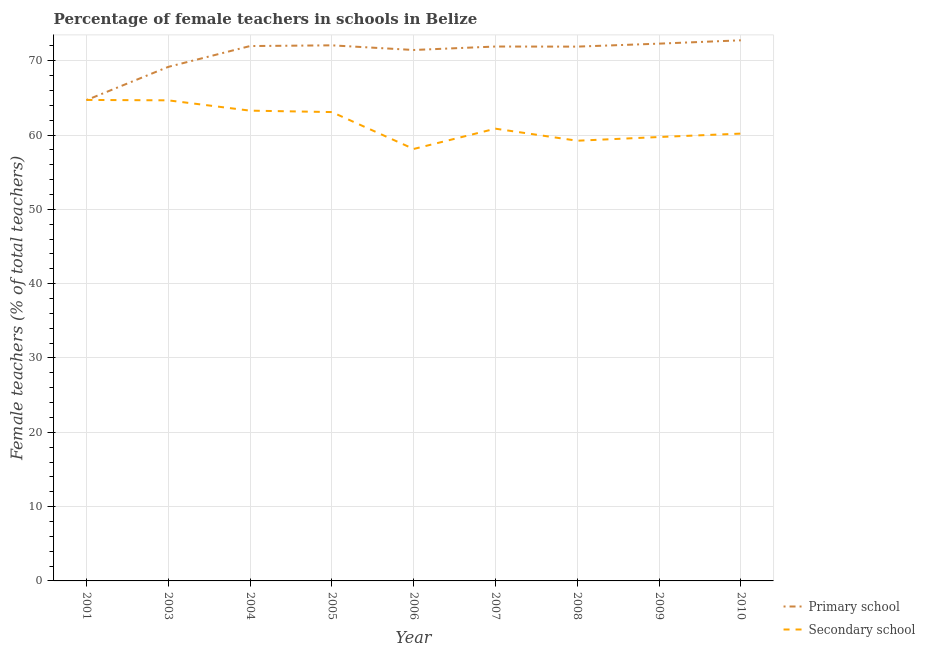How many different coloured lines are there?
Provide a short and direct response. 2. Does the line corresponding to percentage of female teachers in primary schools intersect with the line corresponding to percentage of female teachers in secondary schools?
Offer a very short reply. Yes. What is the percentage of female teachers in secondary schools in 2001?
Provide a short and direct response. 64.73. Across all years, what is the maximum percentage of female teachers in primary schools?
Your answer should be compact. 72.75. Across all years, what is the minimum percentage of female teachers in primary schools?
Give a very brief answer. 64.7. In which year was the percentage of female teachers in primary schools maximum?
Give a very brief answer. 2010. In which year was the percentage of female teachers in primary schools minimum?
Provide a succinct answer. 2001. What is the total percentage of female teachers in primary schools in the graph?
Your answer should be compact. 638.24. What is the difference between the percentage of female teachers in primary schools in 2001 and that in 2004?
Your response must be concise. -7.28. What is the difference between the percentage of female teachers in secondary schools in 2008 and the percentage of female teachers in primary schools in 2003?
Keep it short and to the point. -9.94. What is the average percentage of female teachers in primary schools per year?
Keep it short and to the point. 70.92. In the year 2001, what is the difference between the percentage of female teachers in primary schools and percentage of female teachers in secondary schools?
Your answer should be very brief. -0.03. What is the ratio of the percentage of female teachers in primary schools in 2008 to that in 2009?
Offer a terse response. 0.99. Is the difference between the percentage of female teachers in primary schools in 2005 and 2006 greater than the difference between the percentage of female teachers in secondary schools in 2005 and 2006?
Offer a terse response. No. What is the difference between the highest and the second highest percentage of female teachers in secondary schools?
Offer a very short reply. 0.06. What is the difference between the highest and the lowest percentage of female teachers in primary schools?
Provide a succinct answer. 8.05. In how many years, is the percentage of female teachers in secondary schools greater than the average percentage of female teachers in secondary schools taken over all years?
Offer a terse response. 4. Is the sum of the percentage of female teachers in primary schools in 2004 and 2010 greater than the maximum percentage of female teachers in secondary schools across all years?
Make the answer very short. Yes. Is the percentage of female teachers in primary schools strictly greater than the percentage of female teachers in secondary schools over the years?
Provide a succinct answer. No. Is the percentage of female teachers in primary schools strictly less than the percentage of female teachers in secondary schools over the years?
Make the answer very short. No. Does the graph contain any zero values?
Keep it short and to the point. No. How many legend labels are there?
Keep it short and to the point. 2. How are the legend labels stacked?
Provide a succinct answer. Vertical. What is the title of the graph?
Ensure brevity in your answer.  Percentage of female teachers in schools in Belize. What is the label or title of the Y-axis?
Provide a succinct answer. Female teachers (% of total teachers). What is the Female teachers (% of total teachers) in Primary school in 2001?
Ensure brevity in your answer.  64.7. What is the Female teachers (% of total teachers) in Secondary school in 2001?
Your answer should be compact. 64.73. What is the Female teachers (% of total teachers) in Primary school in 2003?
Offer a very short reply. 69.17. What is the Female teachers (% of total teachers) in Secondary school in 2003?
Your response must be concise. 64.67. What is the Female teachers (% of total teachers) in Primary school in 2004?
Ensure brevity in your answer.  71.98. What is the Female teachers (% of total teachers) of Secondary school in 2004?
Provide a short and direct response. 63.29. What is the Female teachers (% of total teachers) in Primary school in 2005?
Provide a succinct answer. 72.07. What is the Female teachers (% of total teachers) of Secondary school in 2005?
Make the answer very short. 63.09. What is the Female teachers (% of total teachers) in Primary school in 2006?
Your answer should be compact. 71.45. What is the Female teachers (% of total teachers) of Secondary school in 2006?
Your answer should be compact. 58.13. What is the Female teachers (% of total teachers) of Primary school in 2007?
Provide a succinct answer. 71.91. What is the Female teachers (% of total teachers) in Secondary school in 2007?
Give a very brief answer. 60.86. What is the Female teachers (% of total teachers) of Primary school in 2008?
Offer a very short reply. 71.9. What is the Female teachers (% of total teachers) of Secondary school in 2008?
Ensure brevity in your answer.  59.24. What is the Female teachers (% of total teachers) of Primary school in 2009?
Give a very brief answer. 72.3. What is the Female teachers (% of total teachers) in Secondary school in 2009?
Ensure brevity in your answer.  59.74. What is the Female teachers (% of total teachers) in Primary school in 2010?
Ensure brevity in your answer.  72.75. What is the Female teachers (% of total teachers) of Secondary school in 2010?
Provide a short and direct response. 60.2. Across all years, what is the maximum Female teachers (% of total teachers) of Primary school?
Make the answer very short. 72.75. Across all years, what is the maximum Female teachers (% of total teachers) in Secondary school?
Ensure brevity in your answer.  64.73. Across all years, what is the minimum Female teachers (% of total teachers) of Primary school?
Keep it short and to the point. 64.7. Across all years, what is the minimum Female teachers (% of total teachers) of Secondary school?
Offer a very short reply. 58.13. What is the total Female teachers (% of total teachers) of Primary school in the graph?
Your response must be concise. 638.24. What is the total Female teachers (% of total teachers) of Secondary school in the graph?
Provide a short and direct response. 553.93. What is the difference between the Female teachers (% of total teachers) of Primary school in 2001 and that in 2003?
Your answer should be very brief. -4.47. What is the difference between the Female teachers (% of total teachers) of Secondary school in 2001 and that in 2003?
Your answer should be very brief. 0.06. What is the difference between the Female teachers (% of total teachers) in Primary school in 2001 and that in 2004?
Ensure brevity in your answer.  -7.28. What is the difference between the Female teachers (% of total teachers) of Secondary school in 2001 and that in 2004?
Provide a short and direct response. 1.44. What is the difference between the Female teachers (% of total teachers) of Primary school in 2001 and that in 2005?
Ensure brevity in your answer.  -7.37. What is the difference between the Female teachers (% of total teachers) of Secondary school in 2001 and that in 2005?
Offer a terse response. 1.63. What is the difference between the Female teachers (% of total teachers) in Primary school in 2001 and that in 2006?
Ensure brevity in your answer.  -6.75. What is the difference between the Female teachers (% of total teachers) of Secondary school in 2001 and that in 2006?
Offer a very short reply. 6.6. What is the difference between the Female teachers (% of total teachers) in Primary school in 2001 and that in 2007?
Ensure brevity in your answer.  -7.21. What is the difference between the Female teachers (% of total teachers) of Secondary school in 2001 and that in 2007?
Keep it short and to the point. 3.87. What is the difference between the Female teachers (% of total teachers) in Primary school in 2001 and that in 2008?
Your answer should be compact. -7.2. What is the difference between the Female teachers (% of total teachers) of Secondary school in 2001 and that in 2008?
Ensure brevity in your answer.  5.49. What is the difference between the Female teachers (% of total teachers) in Primary school in 2001 and that in 2009?
Give a very brief answer. -7.6. What is the difference between the Female teachers (% of total teachers) in Secondary school in 2001 and that in 2009?
Offer a terse response. 4.99. What is the difference between the Female teachers (% of total teachers) of Primary school in 2001 and that in 2010?
Your answer should be very brief. -8.05. What is the difference between the Female teachers (% of total teachers) of Secondary school in 2001 and that in 2010?
Ensure brevity in your answer.  4.53. What is the difference between the Female teachers (% of total teachers) of Primary school in 2003 and that in 2004?
Provide a succinct answer. -2.8. What is the difference between the Female teachers (% of total teachers) of Secondary school in 2003 and that in 2004?
Offer a terse response. 1.39. What is the difference between the Female teachers (% of total teachers) of Primary school in 2003 and that in 2005?
Provide a succinct answer. -2.9. What is the difference between the Female teachers (% of total teachers) of Secondary school in 2003 and that in 2005?
Your response must be concise. 1.58. What is the difference between the Female teachers (% of total teachers) of Primary school in 2003 and that in 2006?
Offer a very short reply. -2.27. What is the difference between the Female teachers (% of total teachers) in Secondary school in 2003 and that in 2006?
Give a very brief answer. 6.54. What is the difference between the Female teachers (% of total teachers) of Primary school in 2003 and that in 2007?
Ensure brevity in your answer.  -2.74. What is the difference between the Female teachers (% of total teachers) of Secondary school in 2003 and that in 2007?
Provide a short and direct response. 3.81. What is the difference between the Female teachers (% of total teachers) in Primary school in 2003 and that in 2008?
Your answer should be compact. -2.73. What is the difference between the Female teachers (% of total teachers) in Secondary school in 2003 and that in 2008?
Provide a succinct answer. 5.44. What is the difference between the Female teachers (% of total teachers) in Primary school in 2003 and that in 2009?
Provide a short and direct response. -3.13. What is the difference between the Female teachers (% of total teachers) in Secondary school in 2003 and that in 2009?
Your response must be concise. 4.94. What is the difference between the Female teachers (% of total teachers) in Primary school in 2003 and that in 2010?
Give a very brief answer. -3.58. What is the difference between the Female teachers (% of total teachers) of Secondary school in 2003 and that in 2010?
Your response must be concise. 4.48. What is the difference between the Female teachers (% of total teachers) in Primary school in 2004 and that in 2005?
Ensure brevity in your answer.  -0.1. What is the difference between the Female teachers (% of total teachers) in Secondary school in 2004 and that in 2005?
Make the answer very short. 0.19. What is the difference between the Female teachers (% of total teachers) in Primary school in 2004 and that in 2006?
Keep it short and to the point. 0.53. What is the difference between the Female teachers (% of total teachers) in Secondary school in 2004 and that in 2006?
Provide a succinct answer. 5.16. What is the difference between the Female teachers (% of total teachers) of Primary school in 2004 and that in 2007?
Provide a short and direct response. 0.06. What is the difference between the Female teachers (% of total teachers) of Secondary school in 2004 and that in 2007?
Ensure brevity in your answer.  2.43. What is the difference between the Female teachers (% of total teachers) of Primary school in 2004 and that in 2008?
Your answer should be compact. 0.08. What is the difference between the Female teachers (% of total teachers) in Secondary school in 2004 and that in 2008?
Your answer should be very brief. 4.05. What is the difference between the Female teachers (% of total teachers) in Primary school in 2004 and that in 2009?
Offer a very short reply. -0.32. What is the difference between the Female teachers (% of total teachers) of Secondary school in 2004 and that in 2009?
Offer a terse response. 3.55. What is the difference between the Female teachers (% of total teachers) in Primary school in 2004 and that in 2010?
Your answer should be very brief. -0.77. What is the difference between the Female teachers (% of total teachers) of Secondary school in 2004 and that in 2010?
Ensure brevity in your answer.  3.09. What is the difference between the Female teachers (% of total teachers) of Primary school in 2005 and that in 2006?
Keep it short and to the point. 0.63. What is the difference between the Female teachers (% of total teachers) of Secondary school in 2005 and that in 2006?
Your response must be concise. 4.97. What is the difference between the Female teachers (% of total teachers) of Primary school in 2005 and that in 2007?
Your answer should be very brief. 0.16. What is the difference between the Female teachers (% of total teachers) in Secondary school in 2005 and that in 2007?
Offer a very short reply. 2.24. What is the difference between the Female teachers (% of total teachers) of Primary school in 2005 and that in 2008?
Give a very brief answer. 0.17. What is the difference between the Female teachers (% of total teachers) in Secondary school in 2005 and that in 2008?
Your answer should be very brief. 3.86. What is the difference between the Female teachers (% of total teachers) of Primary school in 2005 and that in 2009?
Keep it short and to the point. -0.23. What is the difference between the Female teachers (% of total teachers) in Secondary school in 2005 and that in 2009?
Provide a short and direct response. 3.36. What is the difference between the Female teachers (% of total teachers) of Primary school in 2005 and that in 2010?
Your answer should be compact. -0.68. What is the difference between the Female teachers (% of total teachers) of Secondary school in 2005 and that in 2010?
Your answer should be very brief. 2.9. What is the difference between the Female teachers (% of total teachers) of Primary school in 2006 and that in 2007?
Provide a short and direct response. -0.47. What is the difference between the Female teachers (% of total teachers) of Secondary school in 2006 and that in 2007?
Provide a short and direct response. -2.73. What is the difference between the Female teachers (% of total teachers) in Primary school in 2006 and that in 2008?
Give a very brief answer. -0.45. What is the difference between the Female teachers (% of total teachers) in Secondary school in 2006 and that in 2008?
Give a very brief answer. -1.11. What is the difference between the Female teachers (% of total teachers) of Primary school in 2006 and that in 2009?
Your response must be concise. -0.85. What is the difference between the Female teachers (% of total teachers) in Secondary school in 2006 and that in 2009?
Your answer should be compact. -1.61. What is the difference between the Female teachers (% of total teachers) of Primary school in 2006 and that in 2010?
Provide a short and direct response. -1.3. What is the difference between the Female teachers (% of total teachers) in Secondary school in 2006 and that in 2010?
Your answer should be very brief. -2.07. What is the difference between the Female teachers (% of total teachers) of Primary school in 2007 and that in 2008?
Keep it short and to the point. 0.01. What is the difference between the Female teachers (% of total teachers) in Secondary school in 2007 and that in 2008?
Your answer should be very brief. 1.62. What is the difference between the Female teachers (% of total teachers) in Primary school in 2007 and that in 2009?
Give a very brief answer. -0.39. What is the difference between the Female teachers (% of total teachers) of Secondary school in 2007 and that in 2009?
Give a very brief answer. 1.12. What is the difference between the Female teachers (% of total teachers) in Primary school in 2007 and that in 2010?
Provide a short and direct response. -0.84. What is the difference between the Female teachers (% of total teachers) in Secondary school in 2007 and that in 2010?
Provide a succinct answer. 0.66. What is the difference between the Female teachers (% of total teachers) in Primary school in 2008 and that in 2009?
Your answer should be compact. -0.4. What is the difference between the Female teachers (% of total teachers) of Secondary school in 2008 and that in 2009?
Offer a terse response. -0.5. What is the difference between the Female teachers (% of total teachers) in Primary school in 2008 and that in 2010?
Provide a short and direct response. -0.85. What is the difference between the Female teachers (% of total teachers) of Secondary school in 2008 and that in 2010?
Offer a terse response. -0.96. What is the difference between the Female teachers (% of total teachers) of Primary school in 2009 and that in 2010?
Your answer should be compact. -0.45. What is the difference between the Female teachers (% of total teachers) in Secondary school in 2009 and that in 2010?
Provide a succinct answer. -0.46. What is the difference between the Female teachers (% of total teachers) in Primary school in 2001 and the Female teachers (% of total teachers) in Secondary school in 2003?
Your answer should be very brief. 0.03. What is the difference between the Female teachers (% of total teachers) of Primary school in 2001 and the Female teachers (% of total teachers) of Secondary school in 2004?
Give a very brief answer. 1.41. What is the difference between the Female teachers (% of total teachers) of Primary school in 2001 and the Female teachers (% of total teachers) of Secondary school in 2005?
Offer a very short reply. 1.61. What is the difference between the Female teachers (% of total teachers) in Primary school in 2001 and the Female teachers (% of total teachers) in Secondary school in 2006?
Provide a short and direct response. 6.57. What is the difference between the Female teachers (% of total teachers) in Primary school in 2001 and the Female teachers (% of total teachers) in Secondary school in 2007?
Your answer should be compact. 3.84. What is the difference between the Female teachers (% of total teachers) of Primary school in 2001 and the Female teachers (% of total teachers) of Secondary school in 2008?
Provide a succinct answer. 5.46. What is the difference between the Female teachers (% of total teachers) in Primary school in 2001 and the Female teachers (% of total teachers) in Secondary school in 2009?
Your answer should be very brief. 4.96. What is the difference between the Female teachers (% of total teachers) in Primary school in 2001 and the Female teachers (% of total teachers) in Secondary school in 2010?
Keep it short and to the point. 4.5. What is the difference between the Female teachers (% of total teachers) in Primary school in 2003 and the Female teachers (% of total teachers) in Secondary school in 2004?
Make the answer very short. 5.89. What is the difference between the Female teachers (% of total teachers) of Primary school in 2003 and the Female teachers (% of total teachers) of Secondary school in 2005?
Make the answer very short. 6.08. What is the difference between the Female teachers (% of total teachers) of Primary school in 2003 and the Female teachers (% of total teachers) of Secondary school in 2006?
Provide a short and direct response. 11.05. What is the difference between the Female teachers (% of total teachers) of Primary school in 2003 and the Female teachers (% of total teachers) of Secondary school in 2007?
Your answer should be compact. 8.32. What is the difference between the Female teachers (% of total teachers) in Primary school in 2003 and the Female teachers (% of total teachers) in Secondary school in 2008?
Offer a terse response. 9.94. What is the difference between the Female teachers (% of total teachers) in Primary school in 2003 and the Female teachers (% of total teachers) in Secondary school in 2009?
Your answer should be very brief. 9.44. What is the difference between the Female teachers (% of total teachers) in Primary school in 2003 and the Female teachers (% of total teachers) in Secondary school in 2010?
Provide a short and direct response. 8.98. What is the difference between the Female teachers (% of total teachers) in Primary school in 2004 and the Female teachers (% of total teachers) in Secondary school in 2005?
Your answer should be very brief. 8.88. What is the difference between the Female teachers (% of total teachers) in Primary school in 2004 and the Female teachers (% of total teachers) in Secondary school in 2006?
Offer a terse response. 13.85. What is the difference between the Female teachers (% of total teachers) in Primary school in 2004 and the Female teachers (% of total teachers) in Secondary school in 2007?
Ensure brevity in your answer.  11.12. What is the difference between the Female teachers (% of total teachers) of Primary school in 2004 and the Female teachers (% of total teachers) of Secondary school in 2008?
Make the answer very short. 12.74. What is the difference between the Female teachers (% of total teachers) in Primary school in 2004 and the Female teachers (% of total teachers) in Secondary school in 2009?
Your response must be concise. 12.24. What is the difference between the Female teachers (% of total teachers) in Primary school in 2004 and the Female teachers (% of total teachers) in Secondary school in 2010?
Ensure brevity in your answer.  11.78. What is the difference between the Female teachers (% of total teachers) in Primary school in 2005 and the Female teachers (% of total teachers) in Secondary school in 2006?
Your response must be concise. 13.95. What is the difference between the Female teachers (% of total teachers) in Primary school in 2005 and the Female teachers (% of total teachers) in Secondary school in 2007?
Offer a terse response. 11.22. What is the difference between the Female teachers (% of total teachers) in Primary school in 2005 and the Female teachers (% of total teachers) in Secondary school in 2008?
Your answer should be very brief. 12.84. What is the difference between the Female teachers (% of total teachers) of Primary school in 2005 and the Female teachers (% of total teachers) of Secondary school in 2009?
Provide a succinct answer. 12.34. What is the difference between the Female teachers (% of total teachers) in Primary school in 2005 and the Female teachers (% of total teachers) in Secondary school in 2010?
Keep it short and to the point. 11.88. What is the difference between the Female teachers (% of total teachers) in Primary school in 2006 and the Female teachers (% of total teachers) in Secondary school in 2007?
Offer a very short reply. 10.59. What is the difference between the Female teachers (% of total teachers) in Primary school in 2006 and the Female teachers (% of total teachers) in Secondary school in 2008?
Keep it short and to the point. 12.21. What is the difference between the Female teachers (% of total teachers) of Primary school in 2006 and the Female teachers (% of total teachers) of Secondary school in 2009?
Your response must be concise. 11.71. What is the difference between the Female teachers (% of total teachers) in Primary school in 2006 and the Female teachers (% of total teachers) in Secondary school in 2010?
Offer a very short reply. 11.25. What is the difference between the Female teachers (% of total teachers) in Primary school in 2007 and the Female teachers (% of total teachers) in Secondary school in 2008?
Offer a very short reply. 12.68. What is the difference between the Female teachers (% of total teachers) of Primary school in 2007 and the Female teachers (% of total teachers) of Secondary school in 2009?
Offer a terse response. 12.18. What is the difference between the Female teachers (% of total teachers) in Primary school in 2007 and the Female teachers (% of total teachers) in Secondary school in 2010?
Offer a terse response. 11.72. What is the difference between the Female teachers (% of total teachers) in Primary school in 2008 and the Female teachers (% of total teachers) in Secondary school in 2009?
Make the answer very short. 12.16. What is the difference between the Female teachers (% of total teachers) in Primary school in 2008 and the Female teachers (% of total teachers) in Secondary school in 2010?
Your answer should be compact. 11.71. What is the difference between the Female teachers (% of total teachers) of Primary school in 2009 and the Female teachers (% of total teachers) of Secondary school in 2010?
Your response must be concise. 12.11. What is the average Female teachers (% of total teachers) in Primary school per year?
Ensure brevity in your answer.  70.92. What is the average Female teachers (% of total teachers) of Secondary school per year?
Provide a succinct answer. 61.55. In the year 2001, what is the difference between the Female teachers (% of total teachers) of Primary school and Female teachers (% of total teachers) of Secondary school?
Offer a very short reply. -0.03. In the year 2003, what is the difference between the Female teachers (% of total teachers) in Primary school and Female teachers (% of total teachers) in Secondary school?
Give a very brief answer. 4.5. In the year 2004, what is the difference between the Female teachers (% of total teachers) of Primary school and Female teachers (% of total teachers) of Secondary school?
Your answer should be compact. 8.69. In the year 2005, what is the difference between the Female teachers (% of total teachers) in Primary school and Female teachers (% of total teachers) in Secondary school?
Provide a short and direct response. 8.98. In the year 2006, what is the difference between the Female teachers (% of total teachers) in Primary school and Female teachers (% of total teachers) in Secondary school?
Offer a very short reply. 13.32. In the year 2007, what is the difference between the Female teachers (% of total teachers) in Primary school and Female teachers (% of total teachers) in Secondary school?
Ensure brevity in your answer.  11.06. In the year 2008, what is the difference between the Female teachers (% of total teachers) in Primary school and Female teachers (% of total teachers) in Secondary school?
Offer a very short reply. 12.66. In the year 2009, what is the difference between the Female teachers (% of total teachers) of Primary school and Female teachers (% of total teachers) of Secondary school?
Offer a very short reply. 12.56. In the year 2010, what is the difference between the Female teachers (% of total teachers) of Primary school and Female teachers (% of total teachers) of Secondary school?
Ensure brevity in your answer.  12.56. What is the ratio of the Female teachers (% of total teachers) of Primary school in 2001 to that in 2003?
Your response must be concise. 0.94. What is the ratio of the Female teachers (% of total teachers) in Secondary school in 2001 to that in 2003?
Provide a succinct answer. 1. What is the ratio of the Female teachers (% of total teachers) of Primary school in 2001 to that in 2004?
Provide a short and direct response. 0.9. What is the ratio of the Female teachers (% of total teachers) of Secondary school in 2001 to that in 2004?
Your response must be concise. 1.02. What is the ratio of the Female teachers (% of total teachers) in Primary school in 2001 to that in 2005?
Make the answer very short. 0.9. What is the ratio of the Female teachers (% of total teachers) in Secondary school in 2001 to that in 2005?
Keep it short and to the point. 1.03. What is the ratio of the Female teachers (% of total teachers) of Primary school in 2001 to that in 2006?
Provide a succinct answer. 0.91. What is the ratio of the Female teachers (% of total teachers) in Secondary school in 2001 to that in 2006?
Offer a terse response. 1.11. What is the ratio of the Female teachers (% of total teachers) in Primary school in 2001 to that in 2007?
Keep it short and to the point. 0.9. What is the ratio of the Female teachers (% of total teachers) of Secondary school in 2001 to that in 2007?
Ensure brevity in your answer.  1.06. What is the ratio of the Female teachers (% of total teachers) of Primary school in 2001 to that in 2008?
Offer a very short reply. 0.9. What is the ratio of the Female teachers (% of total teachers) in Secondary school in 2001 to that in 2008?
Give a very brief answer. 1.09. What is the ratio of the Female teachers (% of total teachers) in Primary school in 2001 to that in 2009?
Offer a very short reply. 0.89. What is the ratio of the Female teachers (% of total teachers) in Secondary school in 2001 to that in 2009?
Your answer should be compact. 1.08. What is the ratio of the Female teachers (% of total teachers) of Primary school in 2001 to that in 2010?
Your answer should be very brief. 0.89. What is the ratio of the Female teachers (% of total teachers) of Secondary school in 2001 to that in 2010?
Keep it short and to the point. 1.08. What is the ratio of the Female teachers (% of total teachers) of Secondary school in 2003 to that in 2004?
Make the answer very short. 1.02. What is the ratio of the Female teachers (% of total teachers) of Primary school in 2003 to that in 2005?
Keep it short and to the point. 0.96. What is the ratio of the Female teachers (% of total teachers) of Secondary school in 2003 to that in 2005?
Give a very brief answer. 1.02. What is the ratio of the Female teachers (% of total teachers) of Primary school in 2003 to that in 2006?
Provide a short and direct response. 0.97. What is the ratio of the Female teachers (% of total teachers) in Secondary school in 2003 to that in 2006?
Make the answer very short. 1.11. What is the ratio of the Female teachers (% of total teachers) in Primary school in 2003 to that in 2007?
Ensure brevity in your answer.  0.96. What is the ratio of the Female teachers (% of total teachers) of Secondary school in 2003 to that in 2007?
Your answer should be very brief. 1.06. What is the ratio of the Female teachers (% of total teachers) in Primary school in 2003 to that in 2008?
Your answer should be compact. 0.96. What is the ratio of the Female teachers (% of total teachers) of Secondary school in 2003 to that in 2008?
Offer a very short reply. 1.09. What is the ratio of the Female teachers (% of total teachers) in Primary school in 2003 to that in 2009?
Give a very brief answer. 0.96. What is the ratio of the Female teachers (% of total teachers) of Secondary school in 2003 to that in 2009?
Offer a very short reply. 1.08. What is the ratio of the Female teachers (% of total teachers) in Primary school in 2003 to that in 2010?
Offer a very short reply. 0.95. What is the ratio of the Female teachers (% of total teachers) in Secondary school in 2003 to that in 2010?
Give a very brief answer. 1.07. What is the ratio of the Female teachers (% of total teachers) in Primary school in 2004 to that in 2005?
Offer a very short reply. 1. What is the ratio of the Female teachers (% of total teachers) in Primary school in 2004 to that in 2006?
Provide a short and direct response. 1.01. What is the ratio of the Female teachers (% of total teachers) of Secondary school in 2004 to that in 2006?
Your answer should be compact. 1.09. What is the ratio of the Female teachers (% of total teachers) of Primary school in 2004 to that in 2007?
Your answer should be very brief. 1. What is the ratio of the Female teachers (% of total teachers) of Secondary school in 2004 to that in 2007?
Your answer should be compact. 1.04. What is the ratio of the Female teachers (% of total teachers) in Secondary school in 2004 to that in 2008?
Provide a succinct answer. 1.07. What is the ratio of the Female teachers (% of total teachers) of Primary school in 2004 to that in 2009?
Make the answer very short. 1. What is the ratio of the Female teachers (% of total teachers) in Secondary school in 2004 to that in 2009?
Offer a terse response. 1.06. What is the ratio of the Female teachers (% of total teachers) in Primary school in 2004 to that in 2010?
Offer a terse response. 0.99. What is the ratio of the Female teachers (% of total teachers) of Secondary school in 2004 to that in 2010?
Make the answer very short. 1.05. What is the ratio of the Female teachers (% of total teachers) of Primary school in 2005 to that in 2006?
Make the answer very short. 1.01. What is the ratio of the Female teachers (% of total teachers) in Secondary school in 2005 to that in 2006?
Your response must be concise. 1.09. What is the ratio of the Female teachers (% of total teachers) in Primary school in 2005 to that in 2007?
Offer a terse response. 1. What is the ratio of the Female teachers (% of total teachers) of Secondary school in 2005 to that in 2007?
Offer a very short reply. 1.04. What is the ratio of the Female teachers (% of total teachers) of Primary school in 2005 to that in 2008?
Ensure brevity in your answer.  1. What is the ratio of the Female teachers (% of total teachers) of Secondary school in 2005 to that in 2008?
Make the answer very short. 1.07. What is the ratio of the Female teachers (% of total teachers) of Secondary school in 2005 to that in 2009?
Offer a terse response. 1.06. What is the ratio of the Female teachers (% of total teachers) in Primary school in 2005 to that in 2010?
Offer a very short reply. 0.99. What is the ratio of the Female teachers (% of total teachers) in Secondary school in 2005 to that in 2010?
Keep it short and to the point. 1.05. What is the ratio of the Female teachers (% of total teachers) in Secondary school in 2006 to that in 2007?
Your response must be concise. 0.96. What is the ratio of the Female teachers (% of total teachers) of Primary school in 2006 to that in 2008?
Provide a short and direct response. 0.99. What is the ratio of the Female teachers (% of total teachers) in Secondary school in 2006 to that in 2008?
Ensure brevity in your answer.  0.98. What is the ratio of the Female teachers (% of total teachers) of Secondary school in 2006 to that in 2009?
Provide a short and direct response. 0.97. What is the ratio of the Female teachers (% of total teachers) in Primary school in 2006 to that in 2010?
Keep it short and to the point. 0.98. What is the ratio of the Female teachers (% of total teachers) in Secondary school in 2006 to that in 2010?
Make the answer very short. 0.97. What is the ratio of the Female teachers (% of total teachers) in Primary school in 2007 to that in 2008?
Ensure brevity in your answer.  1. What is the ratio of the Female teachers (% of total teachers) of Secondary school in 2007 to that in 2008?
Offer a very short reply. 1.03. What is the ratio of the Female teachers (% of total teachers) of Secondary school in 2007 to that in 2009?
Your response must be concise. 1.02. What is the ratio of the Female teachers (% of total teachers) in Primary school in 2007 to that in 2010?
Offer a very short reply. 0.99. What is the ratio of the Female teachers (% of total teachers) of Primary school in 2008 to that in 2010?
Provide a short and direct response. 0.99. What is the ratio of the Female teachers (% of total teachers) in Secondary school in 2008 to that in 2010?
Your response must be concise. 0.98. What is the ratio of the Female teachers (% of total teachers) in Primary school in 2009 to that in 2010?
Keep it short and to the point. 0.99. What is the ratio of the Female teachers (% of total teachers) of Secondary school in 2009 to that in 2010?
Offer a very short reply. 0.99. What is the difference between the highest and the second highest Female teachers (% of total teachers) of Primary school?
Ensure brevity in your answer.  0.45. What is the difference between the highest and the second highest Female teachers (% of total teachers) of Secondary school?
Offer a terse response. 0.06. What is the difference between the highest and the lowest Female teachers (% of total teachers) in Primary school?
Make the answer very short. 8.05. What is the difference between the highest and the lowest Female teachers (% of total teachers) in Secondary school?
Give a very brief answer. 6.6. 